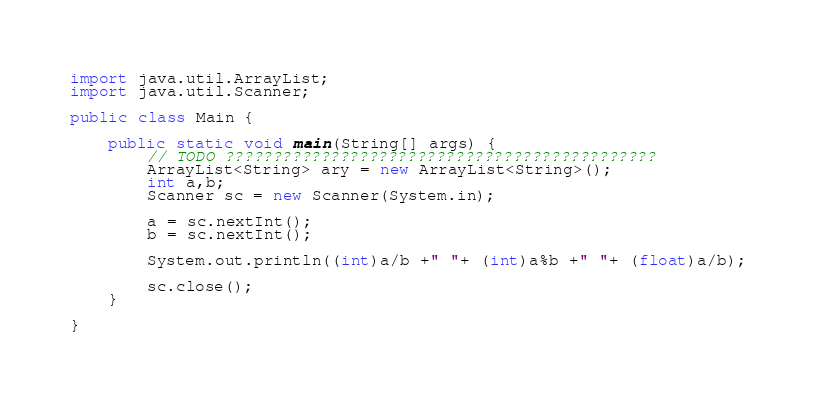<code> <loc_0><loc_0><loc_500><loc_500><_Java_>import java.util.ArrayList;
import java.util.Scanner;

public class Main {

	public static void main(String[] args) {
		// TODO ?????????????????????????????????????????????
		ArrayList<String> ary = new ArrayList<String>();
		int a,b;
		Scanner sc = new Scanner(System.in);

		a = sc.nextInt();
		b = sc.nextInt();

		System.out.println((int)a/b +" "+ (int)a%b +" "+ (float)a/b);

		sc.close();
	}

}</code> 